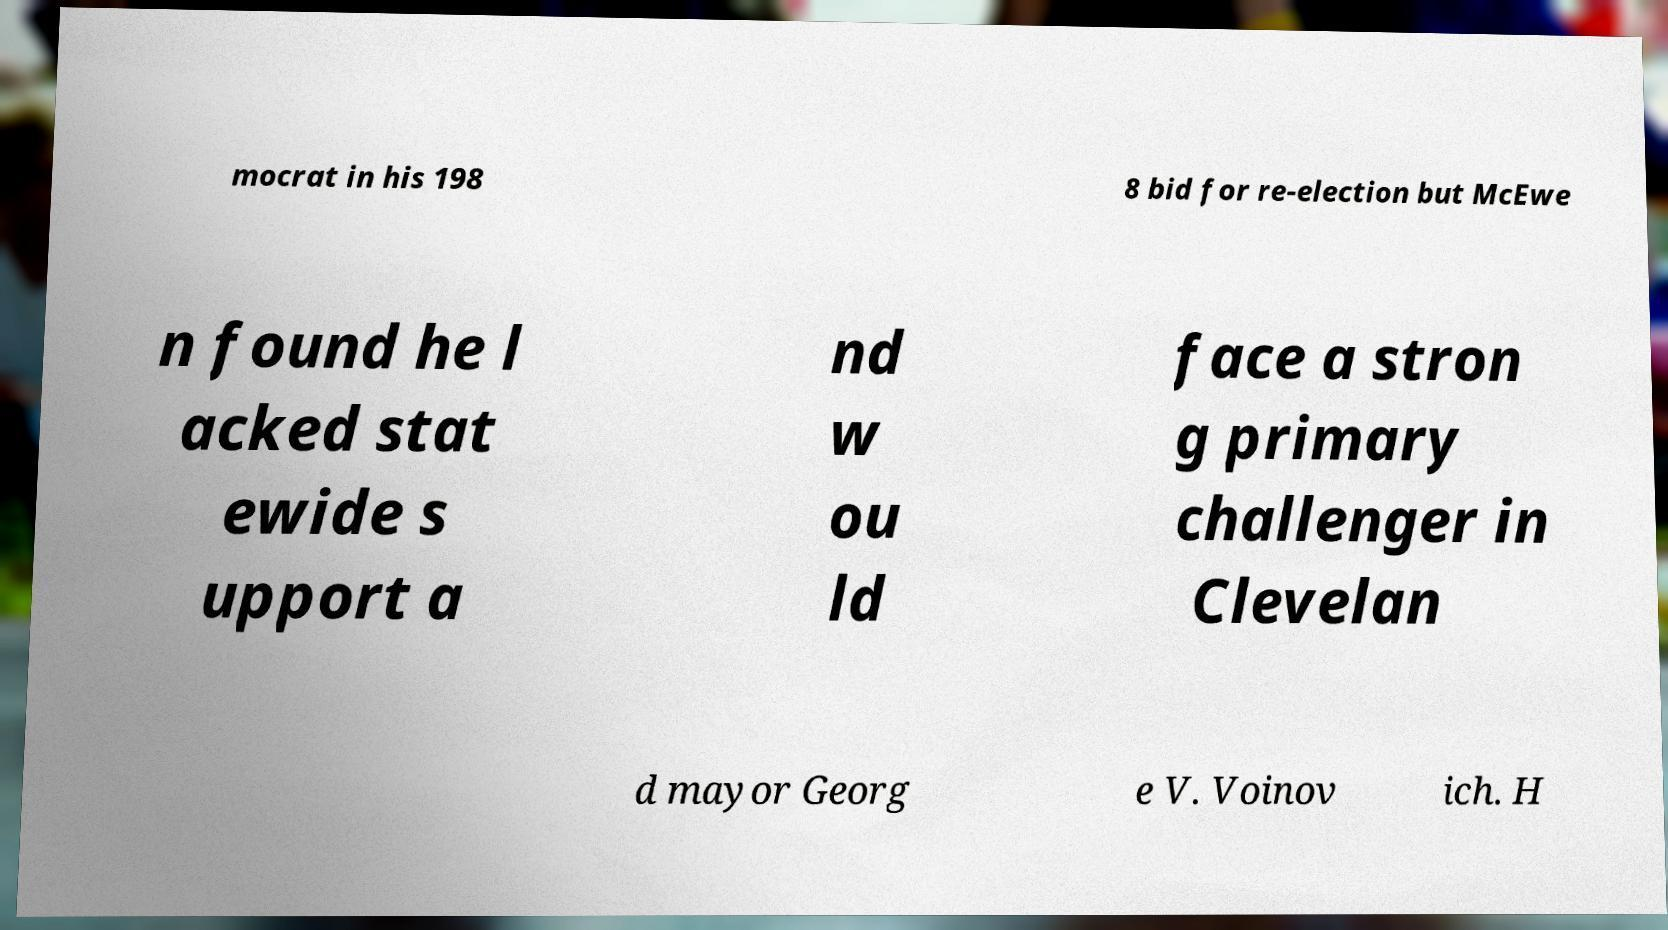Can you accurately transcribe the text from the provided image for me? mocrat in his 198 8 bid for re-election but McEwe n found he l acked stat ewide s upport a nd w ou ld face a stron g primary challenger in Clevelan d mayor Georg e V. Voinov ich. H 